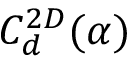<formula> <loc_0><loc_0><loc_500><loc_500>C _ { d } ^ { 2 D } ( \alpha )</formula> 